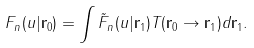<formula> <loc_0><loc_0><loc_500><loc_500>F _ { n } ( u | { \mathbf r } _ { 0 } ) = \int \tilde { F } _ { n } ( u | { \mathbf r } _ { 1 } ) T ( { \mathbf r } _ { 0 } \to { \mathbf r } _ { 1 } ) d { \mathbf r } _ { 1 } .</formula> 